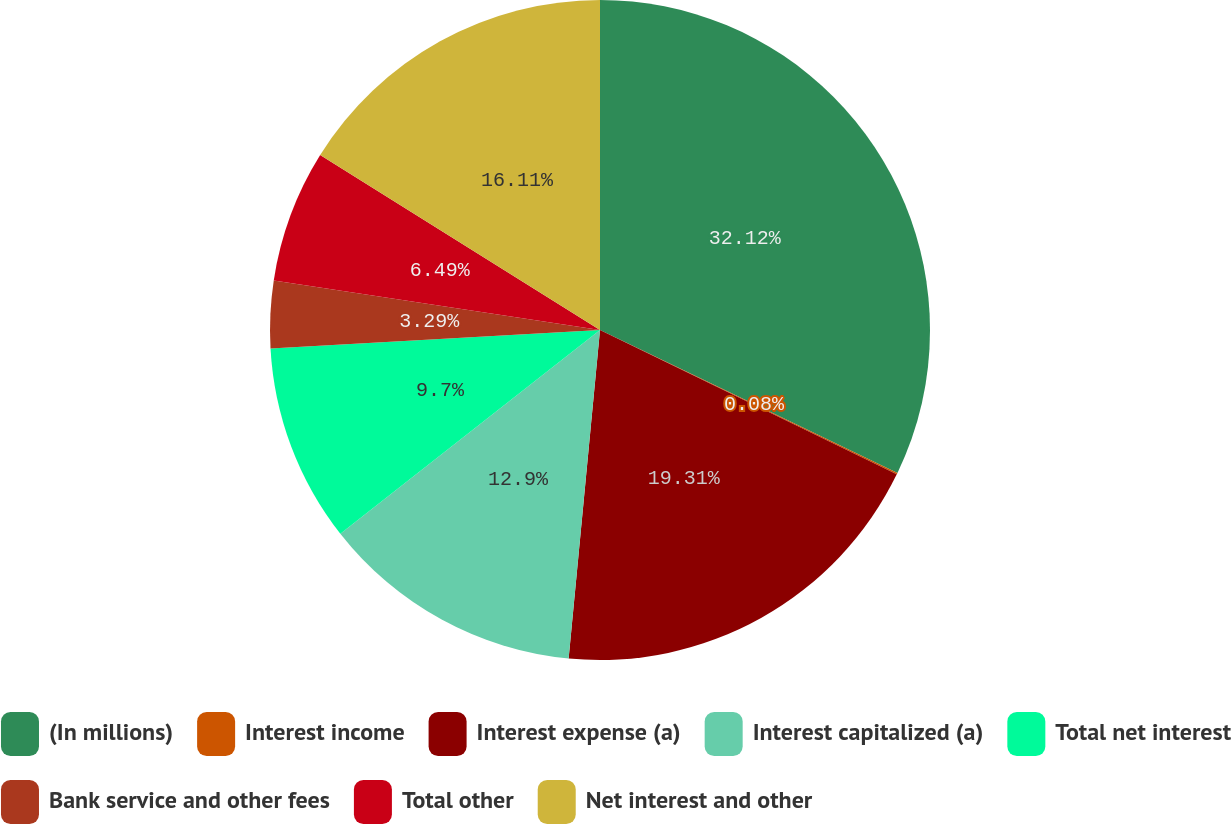<chart> <loc_0><loc_0><loc_500><loc_500><pie_chart><fcel>(In millions)<fcel>Interest income<fcel>Interest expense (a)<fcel>Interest capitalized (a)<fcel>Total net interest<fcel>Bank service and other fees<fcel>Total other<fcel>Net interest and other<nl><fcel>32.13%<fcel>0.08%<fcel>19.31%<fcel>12.9%<fcel>9.7%<fcel>3.29%<fcel>6.49%<fcel>16.11%<nl></chart> 